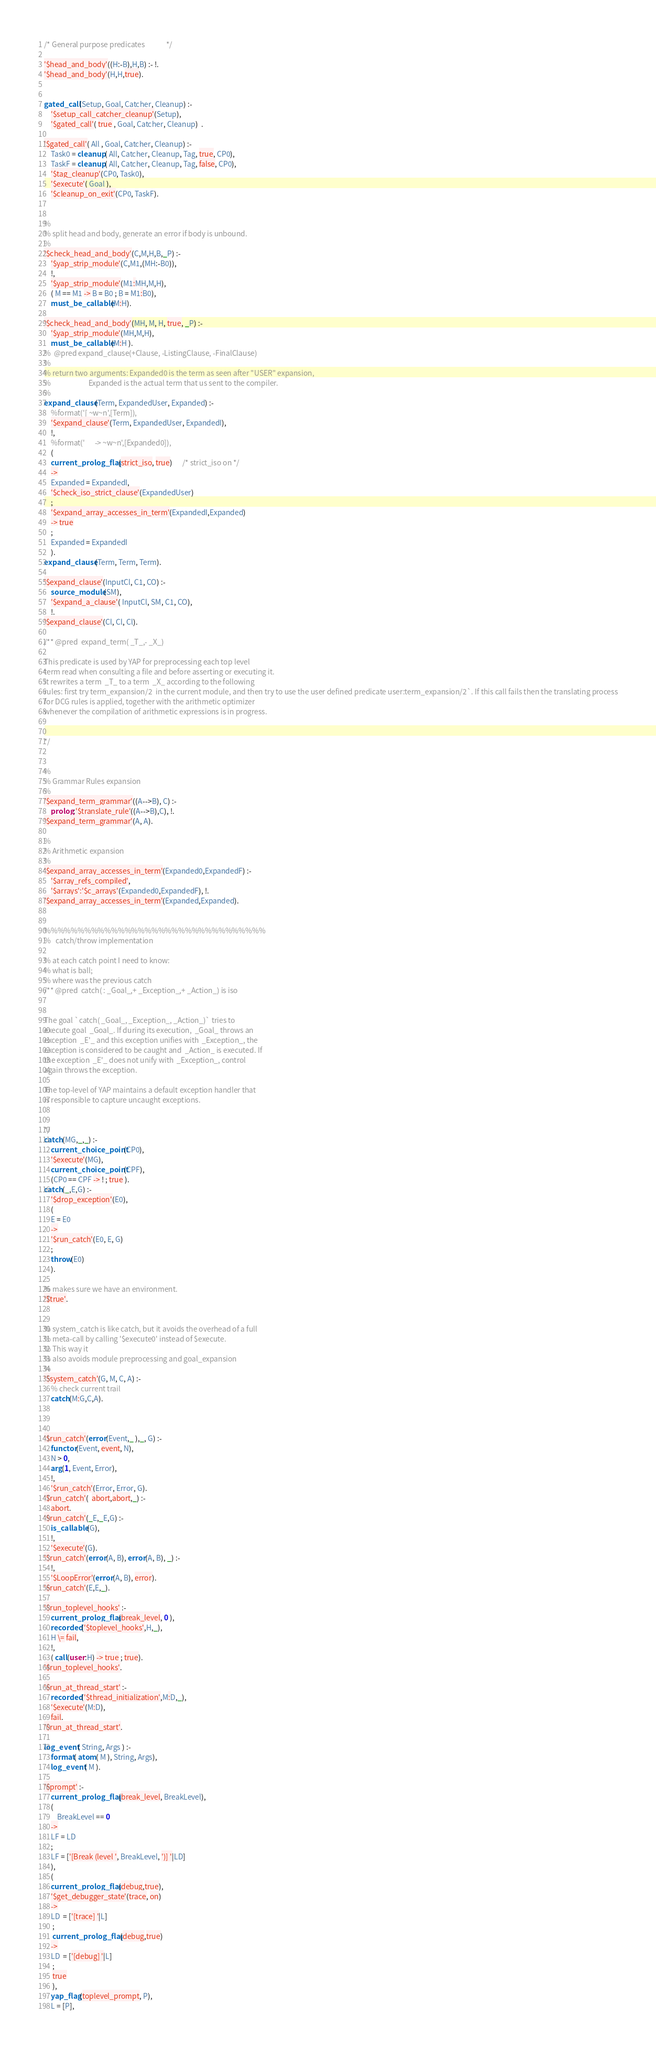Convert code to text. <code><loc_0><loc_0><loc_500><loc_500><_Prolog_>
/* General purpose predicates				*/

'$head_and_body'((H:-B),H,B) :- !.
'$head_and_body'(H,H,true).


gated_call(Setup, Goal, Catcher, Cleanup) :-
    '$setup_call_catcher_cleanup'(Setup),
    '$gated_call'( true , Goal, Catcher, Cleanup)  .

'$gated_call'( All , Goal, Catcher, Cleanup) :-
    Task0 = cleanup( All, Catcher, Cleanup, Tag, true, CP0),
    TaskF = cleanup( All, Catcher, Cleanup, Tag, false, CP0),
    '$tag_cleanup'(CP0, Task0),
    '$execute'( Goal ),
    '$cleanup_on_exit'(CP0, TaskF).


%
% split head and body, generate an error if body is unbound.
%
'$check_head_and_body'(C,M,H,B,_P) :-
    '$yap_strip_module'(C,M1,(MH:-B0)),
    !,
    '$yap_strip_module'(M1:MH,M,H),
    ( M == M1 -> B = B0 ; B = M1:B0),
    must_be_callable(M:H).

'$check_head_and_body'(MH, M, H, true, _P) :-
    '$yap_strip_module'(MH,M,H),
    must_be_callable(M:H ).
%  @pred expand_clause(+Clause, -ListingClause, -FinalClause)
%
% return two arguments: Expanded0 is the term as seen after "USER" expansion,
%                       Expanded is the actual term that us sent to the compiler.
%
expand_clause(Term, ExpandedUser, Expanded) :-
    %format('[ ~w~n',[Term]),
    '$expand_clause'(Term, ExpandedUser, ExpandedI),
    !,
    %format('      -> ~w~n',[Expanded0]),
    (
	current_prolog_flag(strict_iso, true)      /* strict_iso on */
    ->
    Expanded = ExpandedI,
    '$check_iso_strict_clause'(ExpandedUser)
    ;
    '$expand_array_accesses_in_term'(ExpandedI,Expanded)
    -> true
    ;
    Expanded = ExpandedI
    ).
expand_clause(Term, Term, Term).

'$expand_clause'(InputCl, C1, CO) :-
    source_module(SM),
    '$expand_a_clause'( InputCl, SM, C1, CO),
    !.
'$expand_clause'(Cl, Cl, Cl).

/** @pred  expand_term( _T_,- _X_)

This predicate is used by YAP for preprocessing each top level
term read when consulting a file and before asserting or executing it.
It rewrites a term  _T_ to a term  _X_ according to the following
rules: first try term_expansion/2  in the current module, and then try to use the user defined predicate user:term_expansion/2`. If this call fails then the translating process
for DCG rules is applied, together with the arithmetic optimizer
whenever the compilation of arithmetic expressions is in progress.


*/


%
% Grammar Rules expansion
%
'$expand_term_grammar'((A-->B), C) :-
    prolog:'$translate_rule'((A-->B),C), !.
'$expand_term_grammar'(A, A).

%
% Arithmetic expansion
%
'$expand_array_accesses_in_term'(Expanded0,ExpandedF) :-
    '$array_refs_compiled',
    '$arrays':'$c_arrays'(Expanded0,ExpandedF), !.
'$expand_array_accesses_in_term'(Expanded,Expanded).


%%%%%%%%%%%%%%%%%%%%%%%%%%%%%%%%%
%   catch/throw implementation

% at each catch point I need to know:
% what is ball;
% where was the previous catch
/** @pred  catch( : _Goal_,+ _Exception_,+ _Action_) is iso


The goal `catch( _Goal_, _Exception_, _Action_)` tries to
execute goal  _Goal_. If during its execution,  _Goal_ throws an
exception  _E'_ and this exception unifies with  _Exception_, the
exception is considered to be caught and  _Action_ is executed. If
the exception  _E'_ does not unify with  _Exception_, control
again throws the exception.

The top-level of YAP maintains a default exception handler that
is responsible to capture uncaught exceptions.


*/
catch(MG,_,_) :-
    current_choice_point(CP0),
    '$execute'(MG),
    current_choice_point(CPF),
    (CP0 == CPF -> ! ; true ).
catch(_,E,G) :-
    '$drop_exception'(E0),
    (
	E = E0
    ->
    '$run_catch'(E0, E, G)
    ;
    throw(E0)
    ).

% makes sure we have an environment.
'$true'.


% system_catch is like catch, but it avoids the overhead of a full
% meta-call by calling '$execute0' instead of $execute.
% This way it
% also avoids module preprocessing and goal_expansion
%
'$system_catch'(G, M, C, A) :-
    % check current trail
    catch(M:G,C,A).



'$run_catch'(error(Event,_ ),_, G) :-
    functor(Event, event, N),
    N > 0,
    arg(1, Event, Error),
    !,
    '$run_catch'(Error, Error, G).
'$run_catch'(  abort,abort,_) :-
    abort.
'$run_catch'(_E,_E,G) :-
    is_callable(G),
    !,
    '$execute'(G).
'$run_catch'(error(A, B), error(A, B), _) :-
    !,
    '$LoopError'(error(A, B), error).
'$run_catch'(E,E,_).

'$run_toplevel_hooks' :-
    current_prolog_flag(break_level, 0 ),
    recorded('$toplevel_hooks',H,_),
    H \= fail,
    !,
    ( call(user:H) -> true ; true).
'$run_toplevel_hooks'.

'$run_at_thread_start' :-
    recorded('$thread_initialization',M:D,_),
    '$execute'(M:D),
    fail.
'$run_at_thread_start'.

log_event( String, Args ) :-
    format( atom( M ), String, Args),
    log_event( M ).

'$prompt' :-
    current_prolog_flag(break_level, BreakLevel),
    (
	    BreakLevel == 0
    ->
    LF = LD
    ;
    LF = ['[Break (level ', BreakLevel, ')] '|LD]
    ),
    (
	current_prolog_flag(debug,true),
	'$get_debugger_state'(trace, on)
    ->
    LD  = ['[trace] '|L]
     ;
     current_prolog_flag(debug,true)
    ->
    LD  = ['[debug] '|L]
     ;
     true
     ),
    yap_flag(toplevel_prompt, P),
    L = [P],</code> 